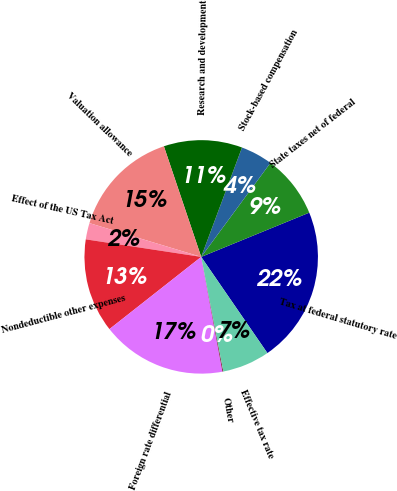<chart> <loc_0><loc_0><loc_500><loc_500><pie_chart><fcel>Tax at federal statutory rate<fcel>State taxes net of federal<fcel>Stock-based compensation<fcel>Research and development<fcel>Valuation allowance<fcel>Effect of the US Tax Act<fcel>Nondeductible other expenses<fcel>Foreign rate differential<fcel>Other<fcel>Effective tax rate<nl><fcel>21.59%<fcel>8.71%<fcel>4.42%<fcel>10.86%<fcel>15.15%<fcel>2.27%<fcel>13.01%<fcel>17.3%<fcel>0.12%<fcel>6.56%<nl></chart> 